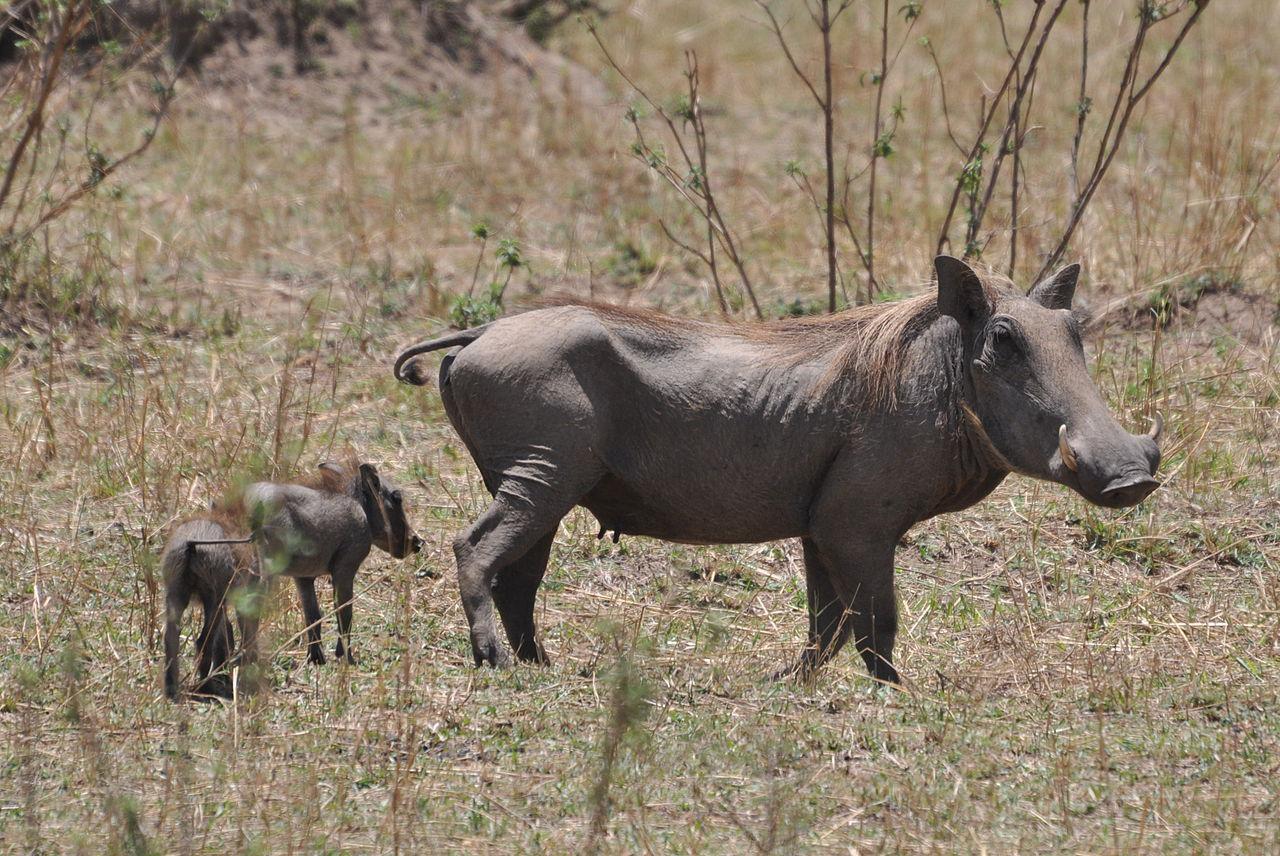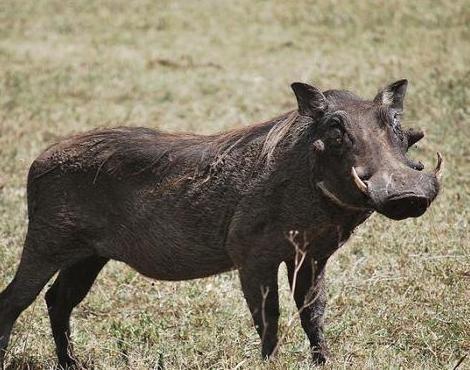The first image is the image on the left, the second image is the image on the right. For the images shown, is this caption "There are more than two animals total." true? Answer yes or no. Yes. 